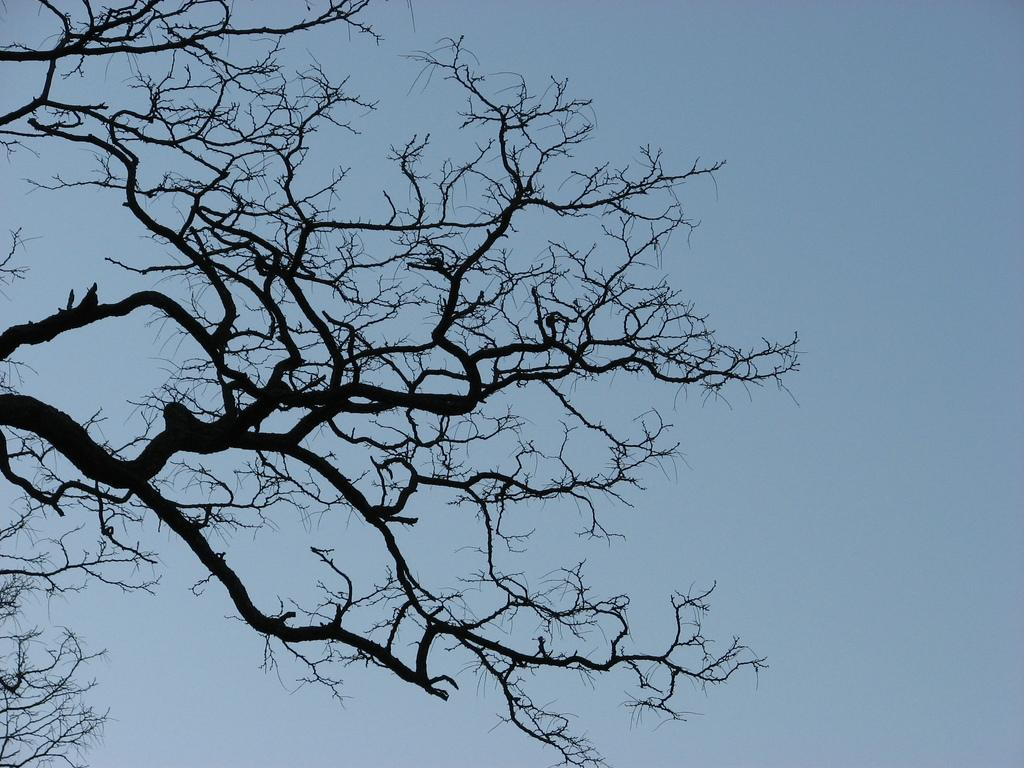What type of tree is in the image? There is a dry tree in the image. What can be seen in the background of the image? The sky is visible in the image. What color is the rose on the shirt in the image? There is no rose or shirt present in the image; it only features a dry tree and the sky. 